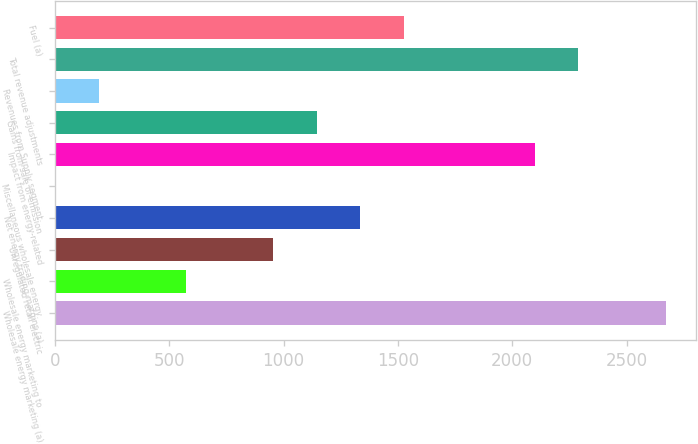Convert chart. <chart><loc_0><loc_0><loc_500><loc_500><bar_chart><fcel>Wholesale energy marketing (a)<fcel>Wholesale energy marketing to<fcel>Unregulated retail electric<fcel>Net energy trading margins (a)<fcel>Miscellaneous wholesale energy<fcel>Impact from energy-related<fcel>Gains from sale of emission<fcel>Revenues from Supply segment<fcel>Total revenue adjustments<fcel>Fuel (a)<nl><fcel>2670.8<fcel>573.1<fcel>954.5<fcel>1335.9<fcel>1<fcel>2098.7<fcel>1145.2<fcel>191.7<fcel>2289.4<fcel>1526.6<nl></chart> 